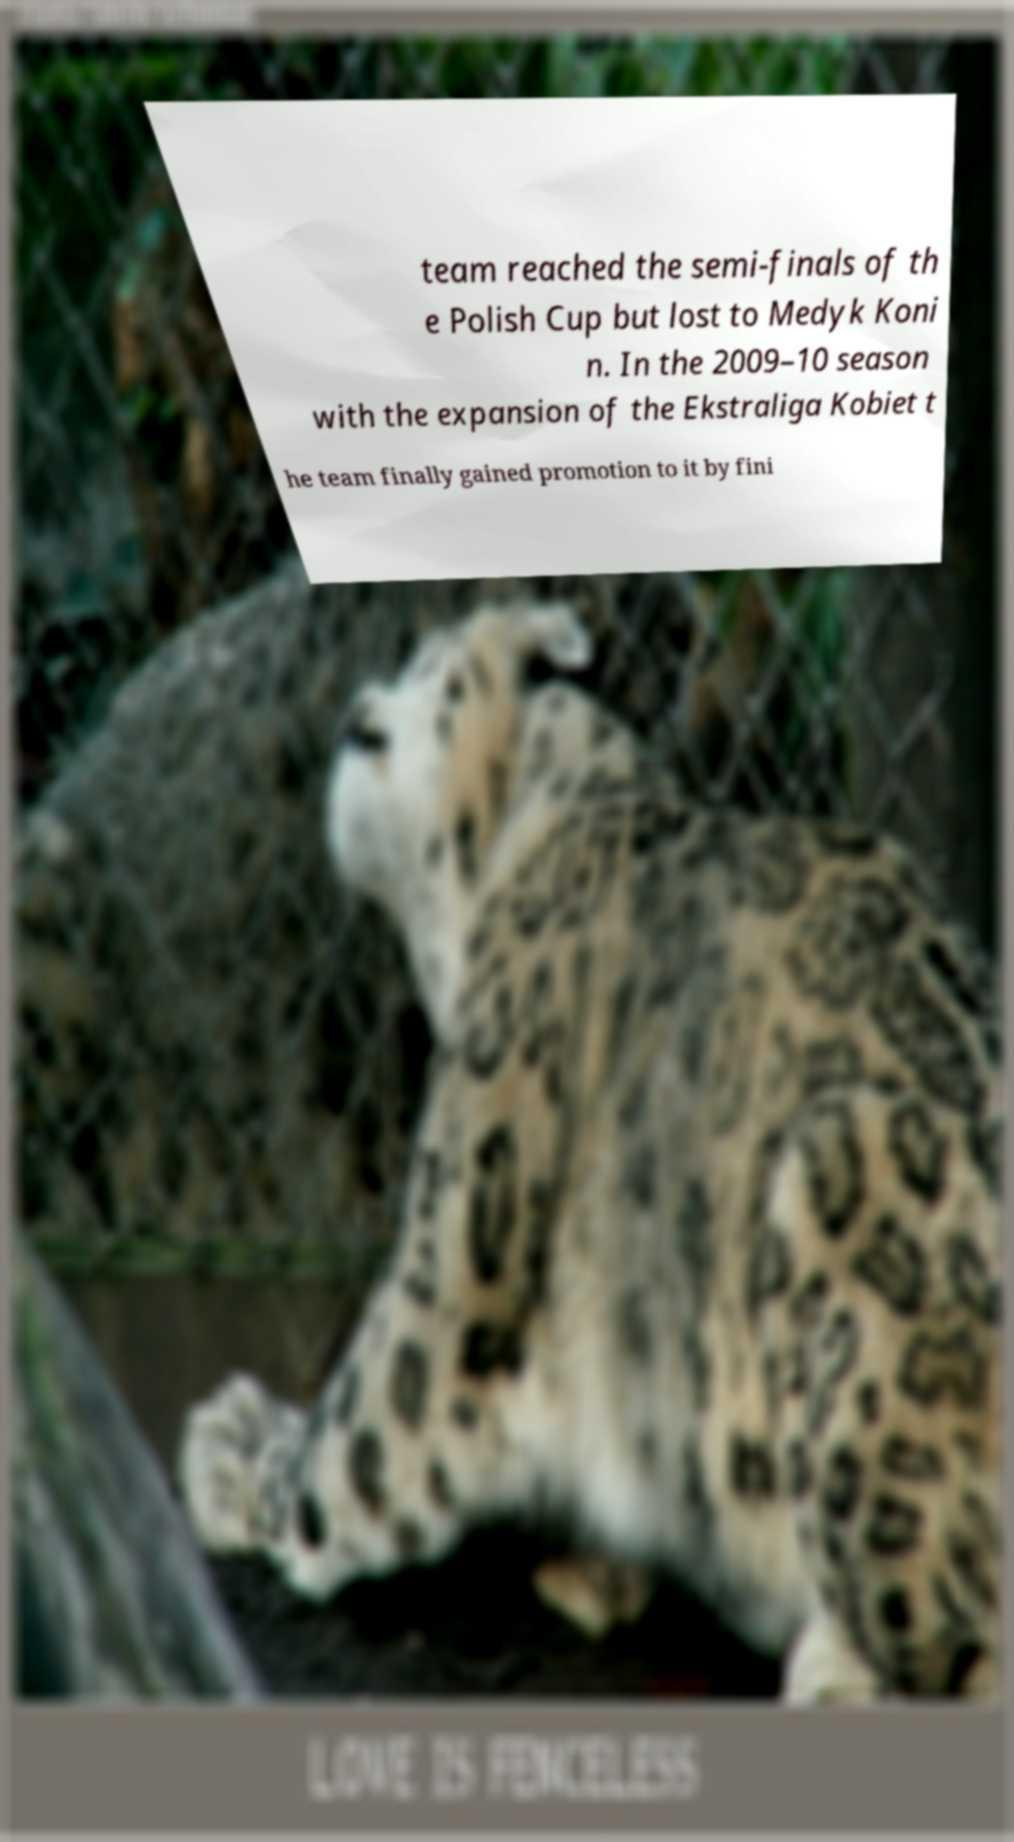Can you read and provide the text displayed in the image?This photo seems to have some interesting text. Can you extract and type it out for me? team reached the semi-finals of th e Polish Cup but lost to Medyk Koni n. In the 2009–10 season with the expansion of the Ekstraliga Kobiet t he team finally gained promotion to it by fini 